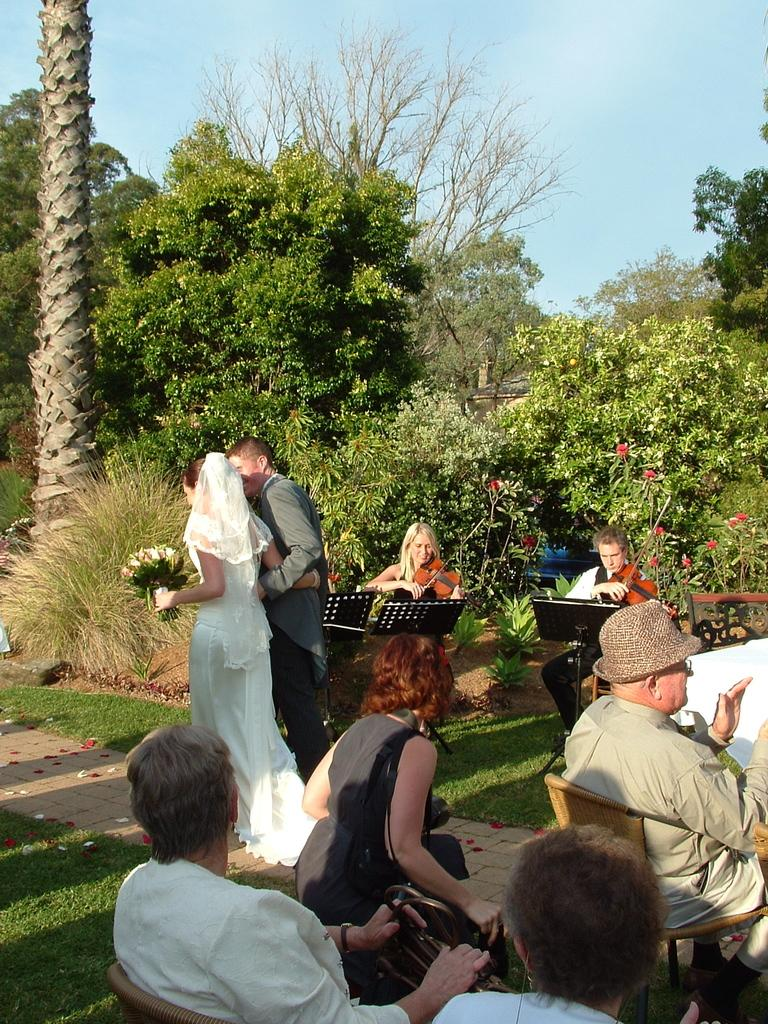How many persons are in the image? There are persons in the image. What are the persons doing in the image? The persons are sitting on chairs. What type of natural environment is visible in the image? There is grass, plants, flowers, and trees in the image. What is visible in the background of the image? The sky is visible in the background of the image. Can you see any goldfish swimming in the image? There are no goldfish present in the image. What type of nail is being used by the person in the image? There is no nail or hammer visible in the image; the persons are sitting on chairs. 